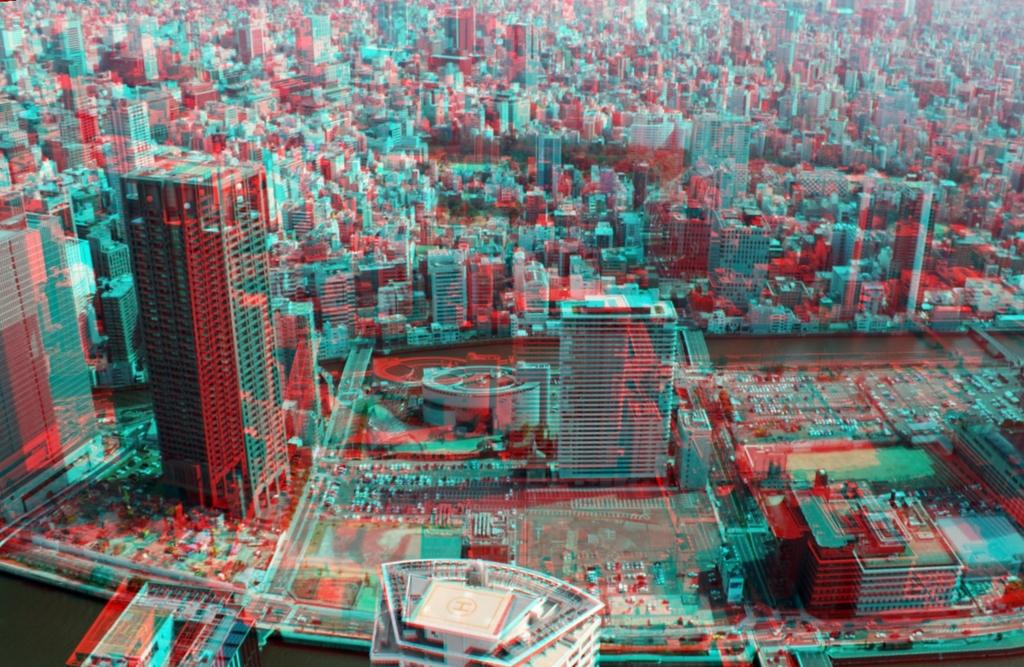What type of structures can be seen in the image? There are buildings and towers in the image. What else can be seen in the image besides structures? There is a road, trees, and vehicles in the image. Can you describe the time of day when the image was likely taken? The image was likely taken during the day, as there is no indication of darkness or artificial lighting. What type of string is being used to hold up the trees in the image? There is no string visible in the image, and the trees are not being held up by any visible means. 